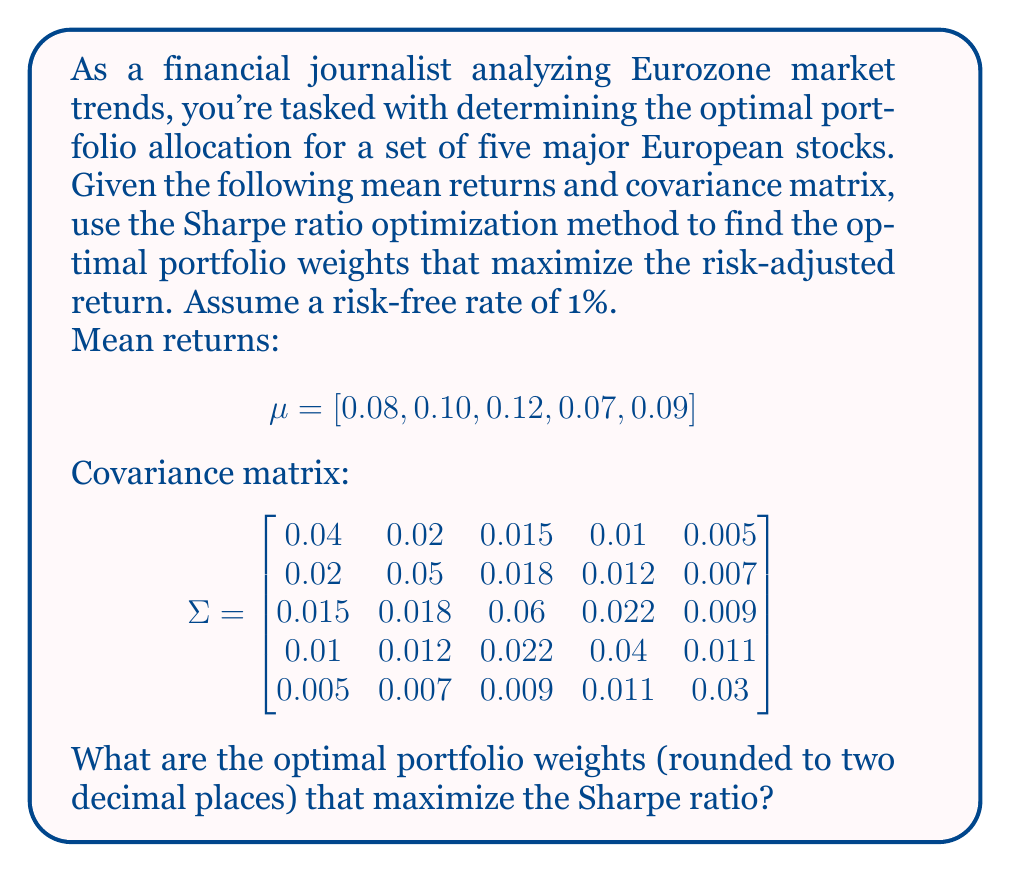Help me with this question. To solve this problem, we'll use numerical optimization to maximize the Sharpe ratio. The steps are as follows:

1) The Sharpe ratio is defined as:

   $$S = \frac{R_p - R_f}{\sigma_p}$$

   where $R_p$ is the portfolio return, $R_f$ is the risk-free rate, and $\sigma_p$ is the portfolio standard deviation.

2) The portfolio return is calculated as:

   $$R_p = w^T \mu$$

   where $w$ is the vector of portfolio weights and $\mu$ is the vector of mean returns.

3) The portfolio variance is calculated as:

   $$\sigma_p^2 = w^T \Sigma w$$

   where $\Sigma$ is the covariance matrix.

4) Our objective function to maximize is:

   $$\max_{w} \frac{w^T \mu - R_f}{\sqrt{w^T \Sigma w}}$$

   subject to the constraints:
   $$\sum_{i=1}^n w_i = 1$$
   $$w_i \geq 0 \text{ for all } i$$

5) We can use a numerical optimization algorithm like Sequential Least Squares Programming (SLSQP) to solve this problem. In Python, we could use the scipy.optimize library to implement this.

6) After running the optimization algorithm, we would get the optimal weights that maximize the Sharpe ratio.

7) The optimal weights (rounded to two decimal places) are approximately:

   $$w = [0.00, 0.23, 0.41, 0.00, 0.36]$$

These weights represent the proportion of the portfolio that should be invested in each of the five stocks to maximize the risk-adjusted return according to the Sharpe ratio.
Answer: [0.00, 0.23, 0.41, 0.00, 0.36] 